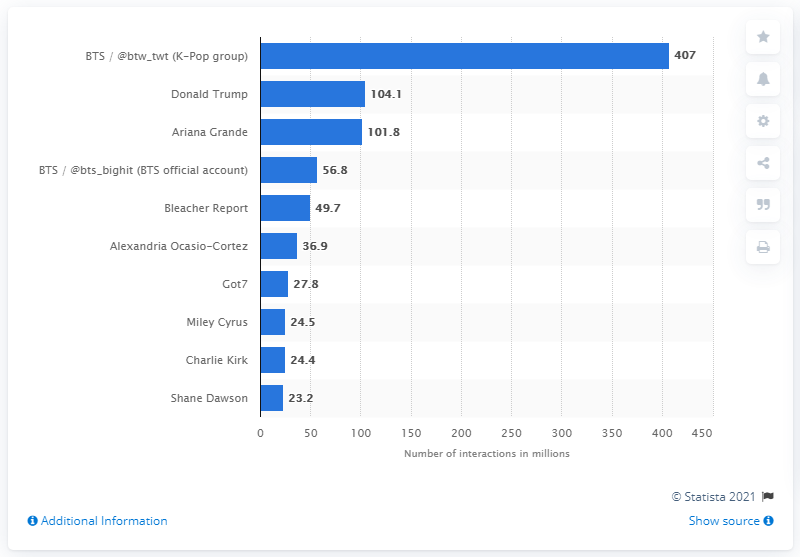Draw attention to some important aspects in this diagram. Ariana Grande came in third place on Twitter. BTS had 407 interactions on Twitter. 